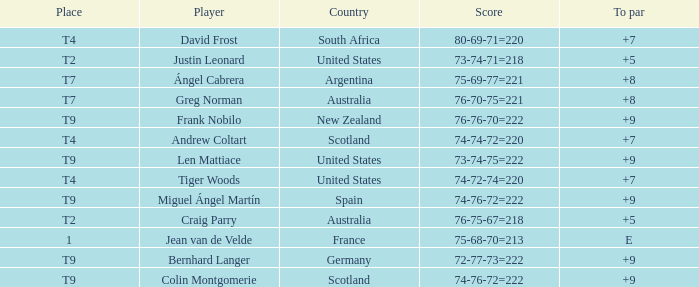For the match in which player David Frost scored a To Par of +7, what was the final score? 80-69-71=220. 